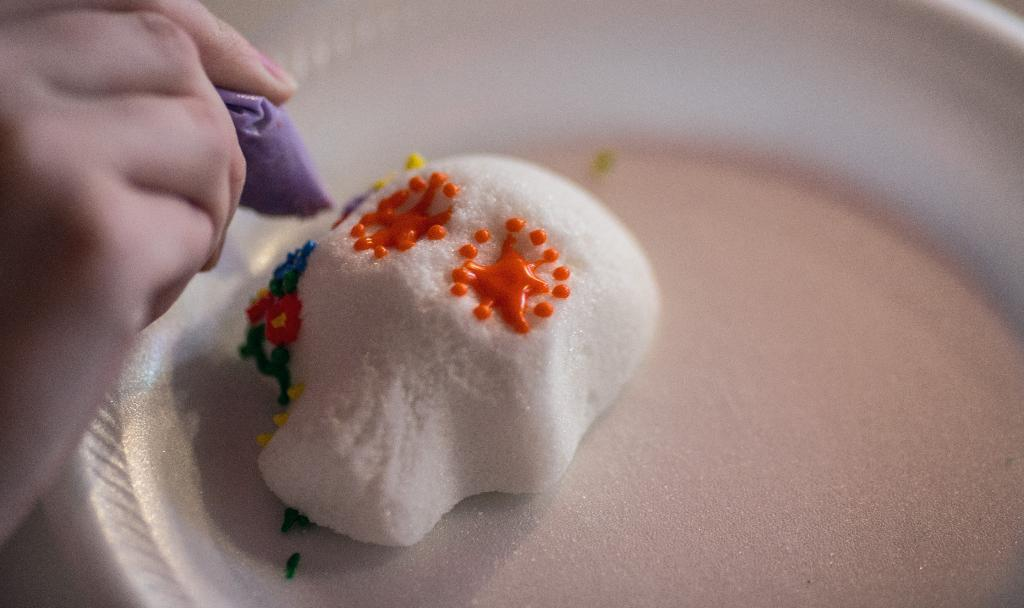What can be seen on the plate in the image? There is an object on the plate in the image. What else is visible in the image besides the plate? There is a hand of a person in the image. What is the person holding in their hand? The person is holding an object in their hand. What type of wool can be seen on the branch in the image? There is no wool or branch present in the image. How many hands are visible in the image? Only one hand is visible in the image. 